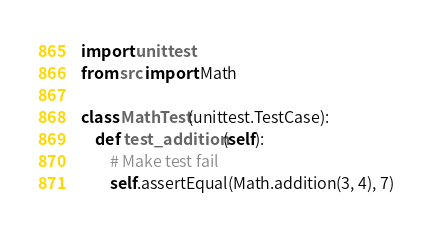Convert code to text. <code><loc_0><loc_0><loc_500><loc_500><_Python_>import unittest
from src import Math

class MathTest(unittest.TestCase):
    def test_addition(self):
        # Make test fail
        self.assertEqual(Math.addition(3, 4), 7)</code> 